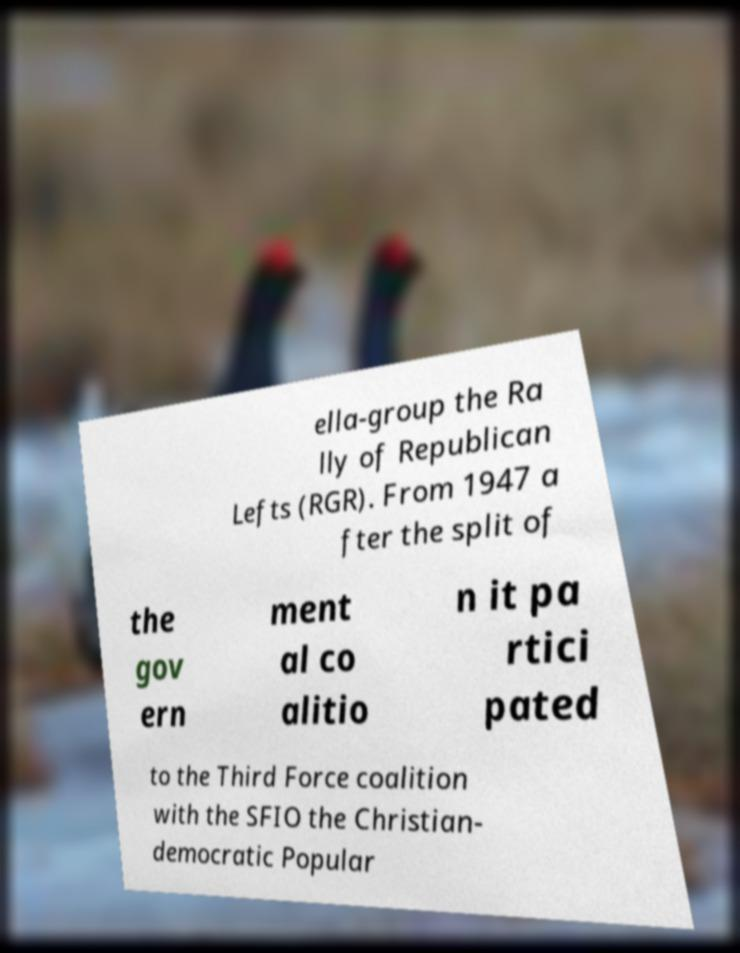Can you accurately transcribe the text from the provided image for me? ella-group the Ra lly of Republican Lefts (RGR). From 1947 a fter the split of the gov ern ment al co alitio n it pa rtici pated to the Third Force coalition with the SFIO the Christian- democratic Popular 